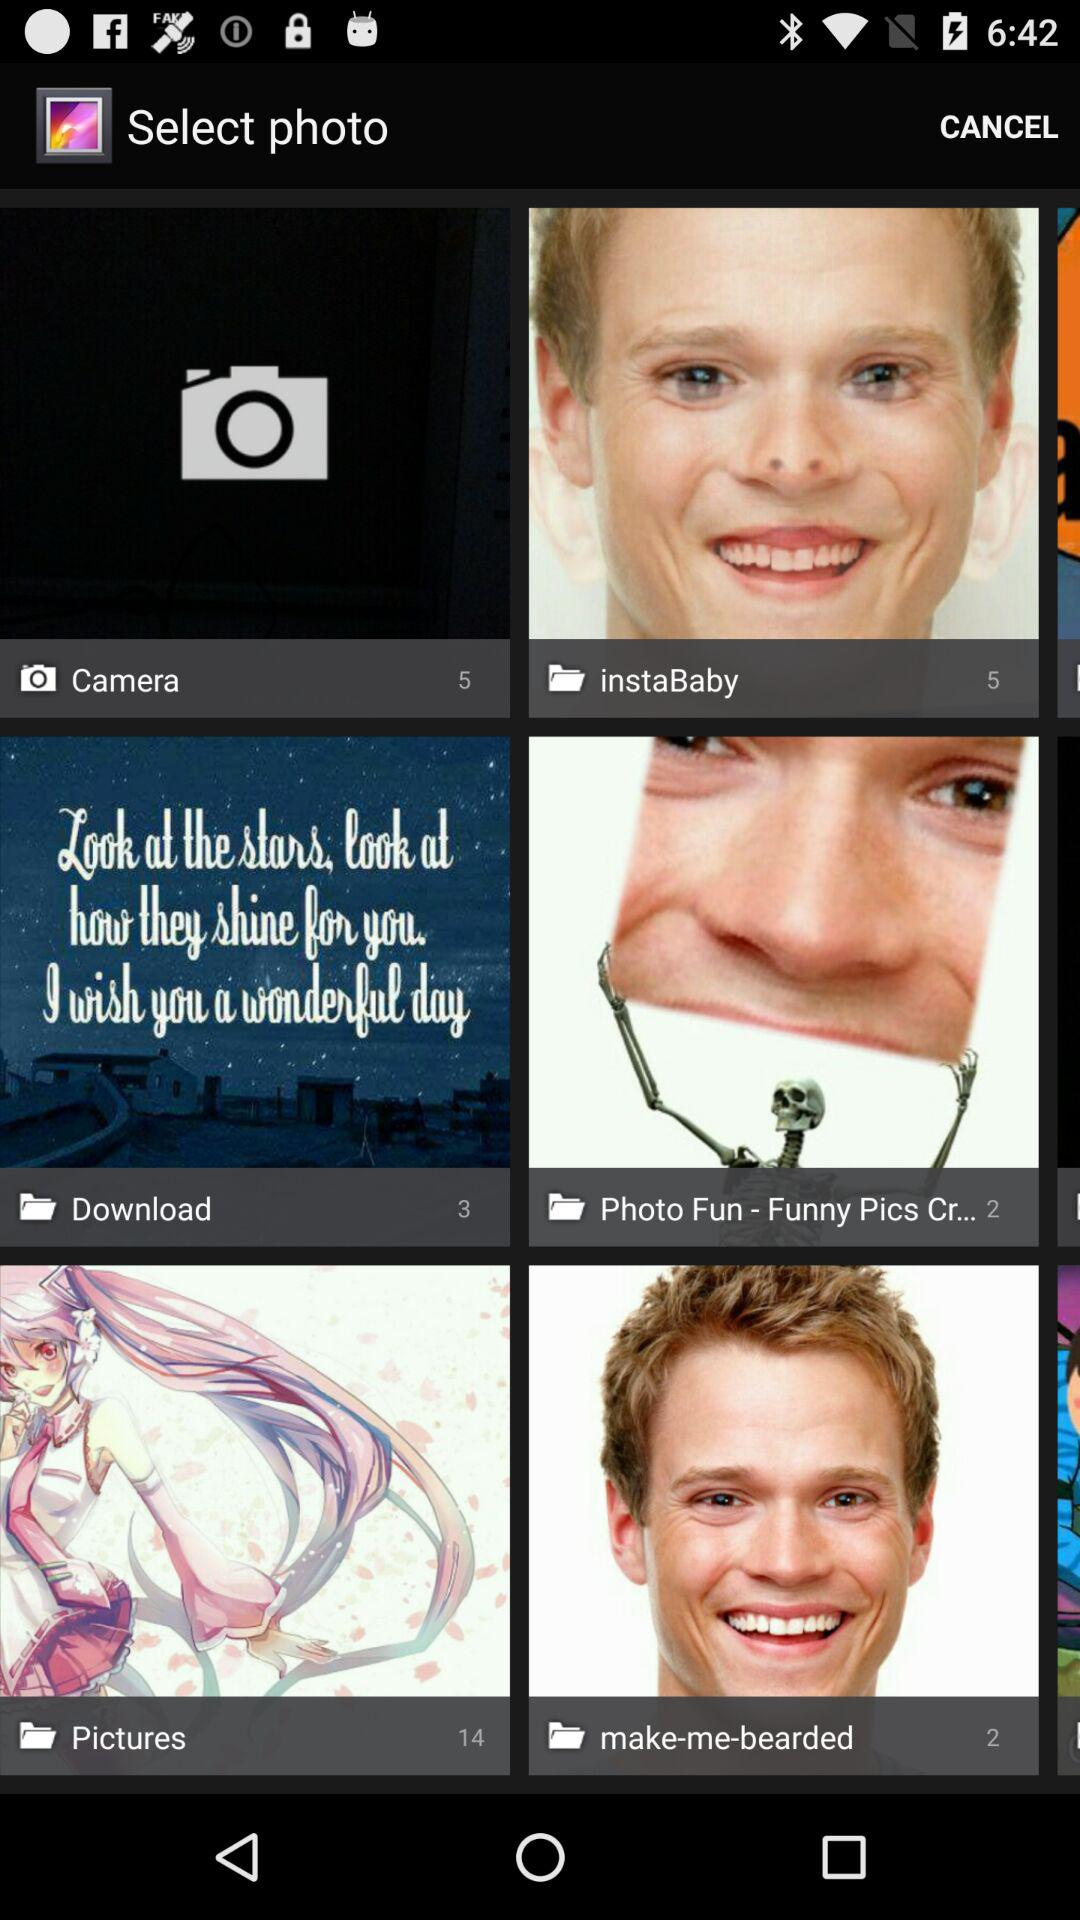What is the count of images in the "Download"? The count is 3. 